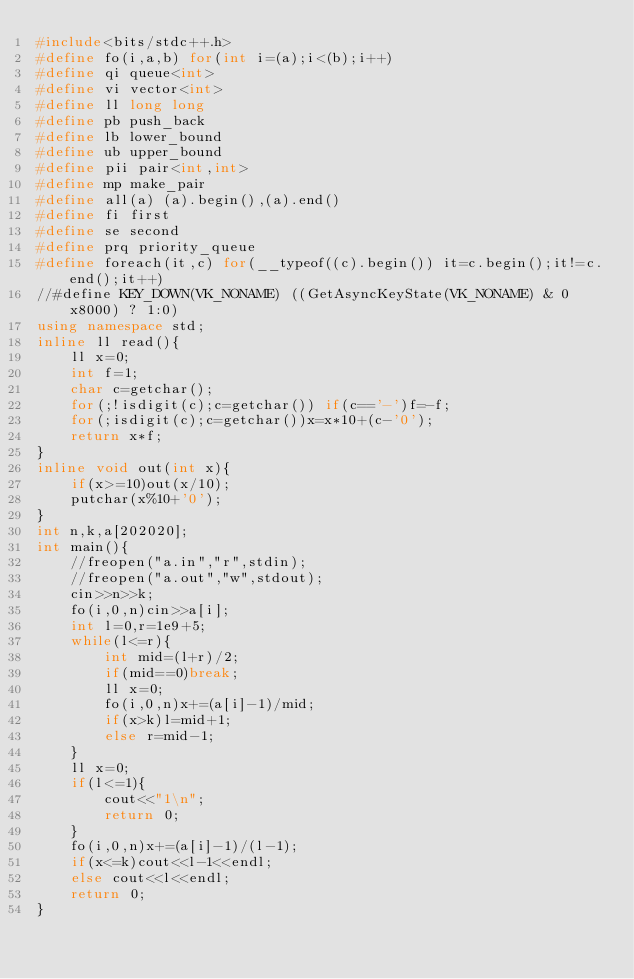<code> <loc_0><loc_0><loc_500><loc_500><_C++_>#include<bits/stdc++.h>
#define fo(i,a,b) for(int i=(a);i<(b);i++)
#define qi queue<int>
#define vi vector<int>
#define ll long long
#define pb push_back
#define lb lower_bound
#define ub upper_bound
#define pii pair<int,int>
#define mp make_pair
#define all(a) (a).begin(),(a).end()
#define fi first
#define se second
#define prq priority_queue
#define foreach(it,c) for(__typeof((c).begin()) it=c.begin();it!=c.end();it++)
//#define KEY_DOWN(VK_NONAME) ((GetAsyncKeyState(VK_NONAME) & 0x8000) ? 1:0)
using namespace std;
inline ll read(){
	ll x=0;
	int f=1;
	char c=getchar();
	for(;!isdigit(c);c=getchar()) if(c=='-')f=-f;
	for(;isdigit(c);c=getchar())x=x*10+(c-'0');
	return x*f;
}
inline void out(int x){
	if(x>=10)out(x/10);
	putchar(x%10+'0');
}
int n,k,a[202020]; 
int main(){
	//freopen("a.in","r",stdin);
	//freopen("a.out","w",stdout);
	cin>>n>>k;
	fo(i,0,n)cin>>a[i];
	int l=0,r=1e9+5;
	while(l<=r){
		int mid=(l+r)/2;
		if(mid==0)break;
		ll x=0;
		fo(i,0,n)x+=(a[i]-1)/mid;
		if(x>k)l=mid+1;
		else r=mid-1;
	}
	ll x=0;
	if(l<=1){
		cout<<"1\n";
		return 0;
	}
	fo(i,0,n)x+=(a[i]-1)/(l-1);
	if(x<=k)cout<<l-1<<endl;
	else cout<<l<<endl;
	return 0;
}</code> 